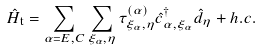Convert formula to latex. <formula><loc_0><loc_0><loc_500><loc_500>\hat { H } _ { \mathrm t } = \sum _ { \alpha = E , C } \sum _ { \xi _ { \alpha } , \eta } \tau _ { \xi _ { \alpha } , \eta } ^ { ( \alpha ) } \hat { c } _ { \alpha , \xi _ { \alpha } } ^ { \dagger } \hat { d } _ { \eta } + h . c .</formula> 